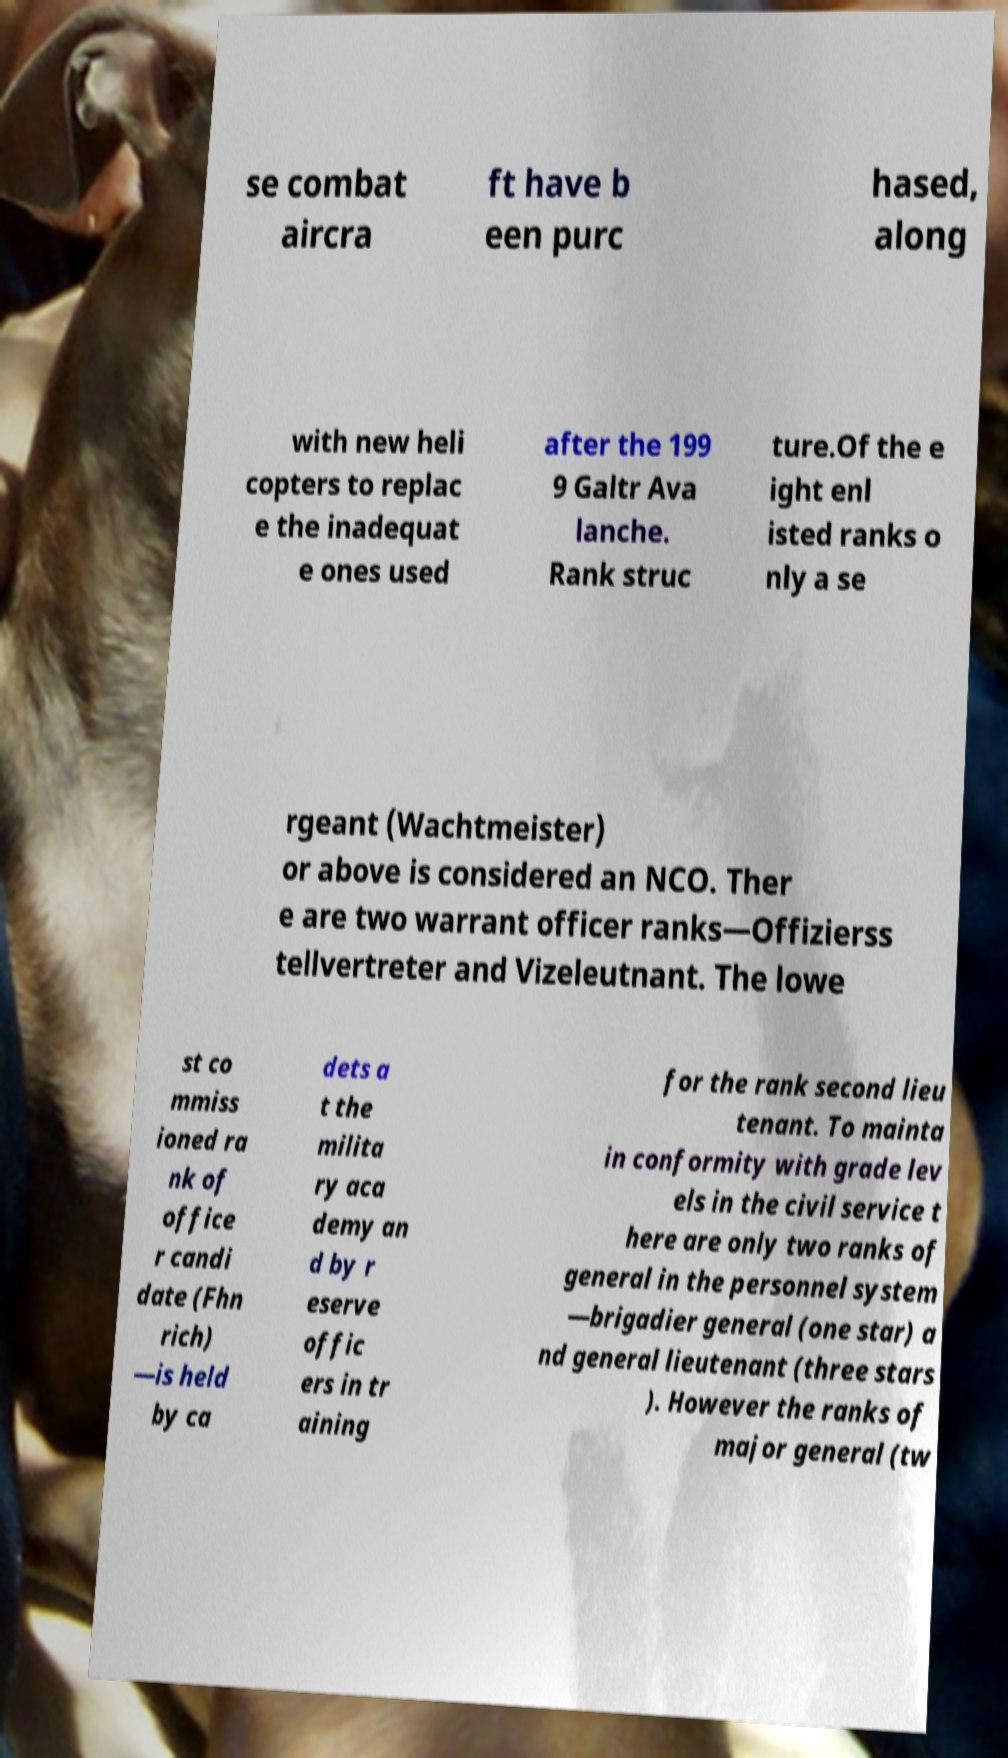What messages or text are displayed in this image? I need them in a readable, typed format. se combat aircra ft have b een purc hased, along with new heli copters to replac e the inadequat e ones used after the 199 9 Galtr Ava lanche. Rank struc ture.Of the e ight enl isted ranks o nly a se rgeant (Wachtmeister) or above is considered an NCO. Ther e are two warrant officer ranks—Offizierss tellvertreter and Vizeleutnant. The lowe st co mmiss ioned ra nk of office r candi date (Fhn rich) —is held by ca dets a t the milita ry aca demy an d by r eserve offic ers in tr aining for the rank second lieu tenant. To mainta in conformity with grade lev els in the civil service t here are only two ranks of general in the personnel system —brigadier general (one star) a nd general lieutenant (three stars ). However the ranks of major general (tw 